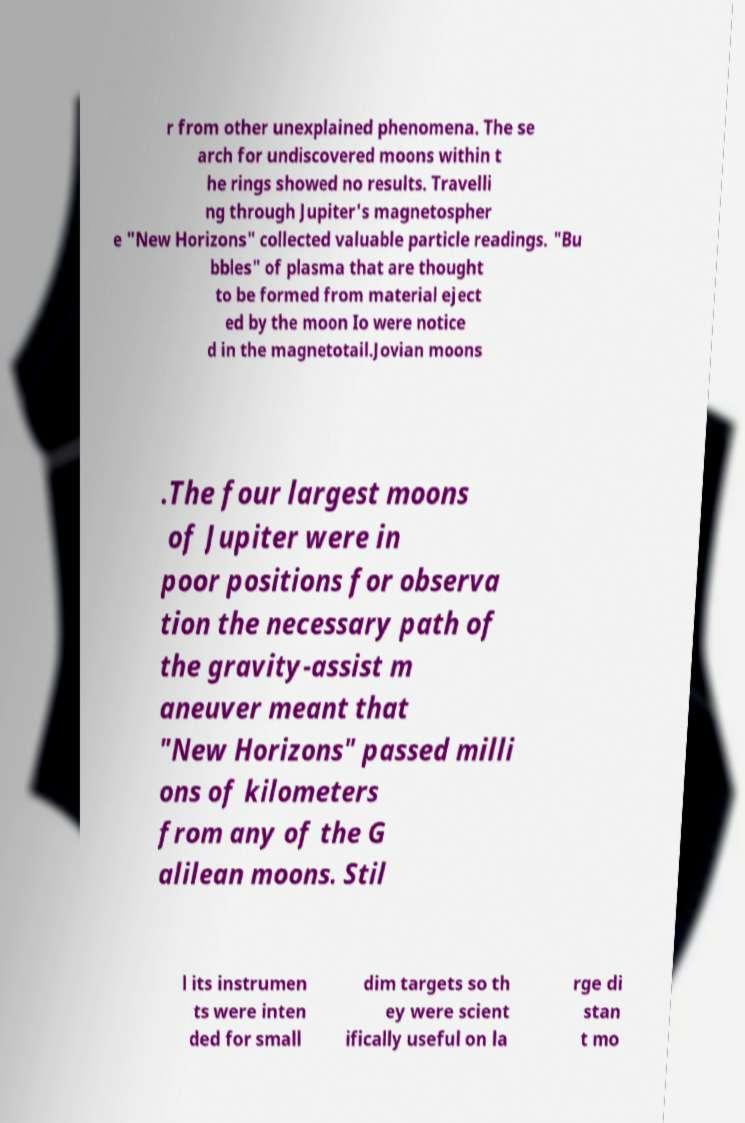Can you read and provide the text displayed in the image?This photo seems to have some interesting text. Can you extract and type it out for me? r from other unexplained phenomena. The se arch for undiscovered moons within t he rings showed no results. Travelli ng through Jupiter's magnetospher e "New Horizons" collected valuable particle readings. "Bu bbles" of plasma that are thought to be formed from material eject ed by the moon Io were notice d in the magnetotail.Jovian moons .The four largest moons of Jupiter were in poor positions for observa tion the necessary path of the gravity-assist m aneuver meant that "New Horizons" passed milli ons of kilometers from any of the G alilean moons. Stil l its instrumen ts were inten ded for small dim targets so th ey were scient ifically useful on la rge di stan t mo 